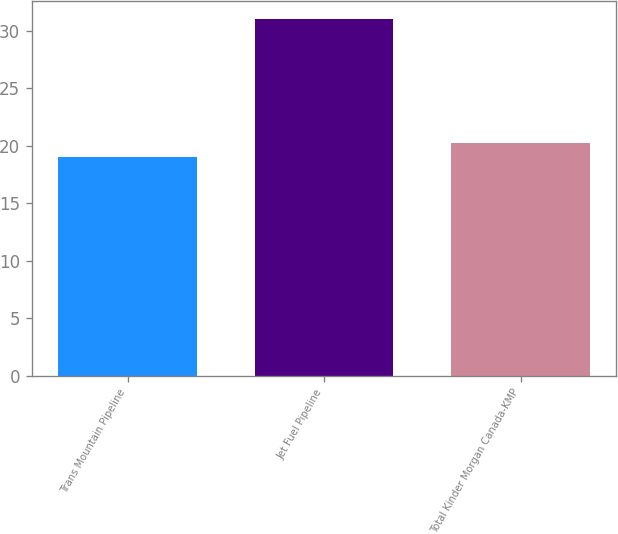Convert chart to OTSL. <chart><loc_0><loc_0><loc_500><loc_500><bar_chart><fcel>Trans Mountain Pipeline<fcel>Jet Fuel Pipeline<fcel>Total Kinder Morgan Canada-KMP<nl><fcel>19<fcel>31<fcel>20.2<nl></chart> 